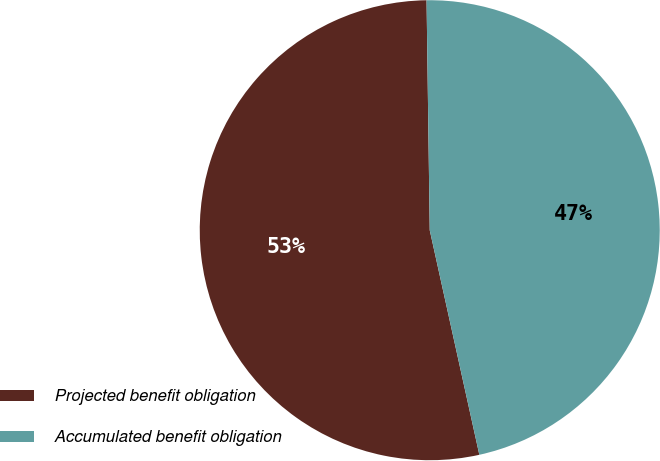Convert chart. <chart><loc_0><loc_0><loc_500><loc_500><pie_chart><fcel>Projected benefit obligation<fcel>Accumulated benefit obligation<nl><fcel>53.24%<fcel>46.76%<nl></chart> 